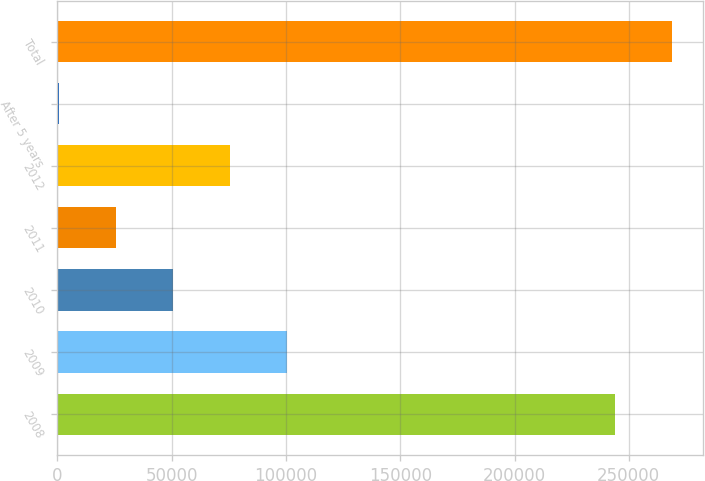Convert chart. <chart><loc_0><loc_0><loc_500><loc_500><bar_chart><fcel>2008<fcel>2009<fcel>2010<fcel>2011<fcel>2012<fcel>After 5 years<fcel>Total<nl><fcel>243923<fcel>100311<fcel>50455.4<fcel>25527.7<fcel>75383.1<fcel>600<fcel>268851<nl></chart> 